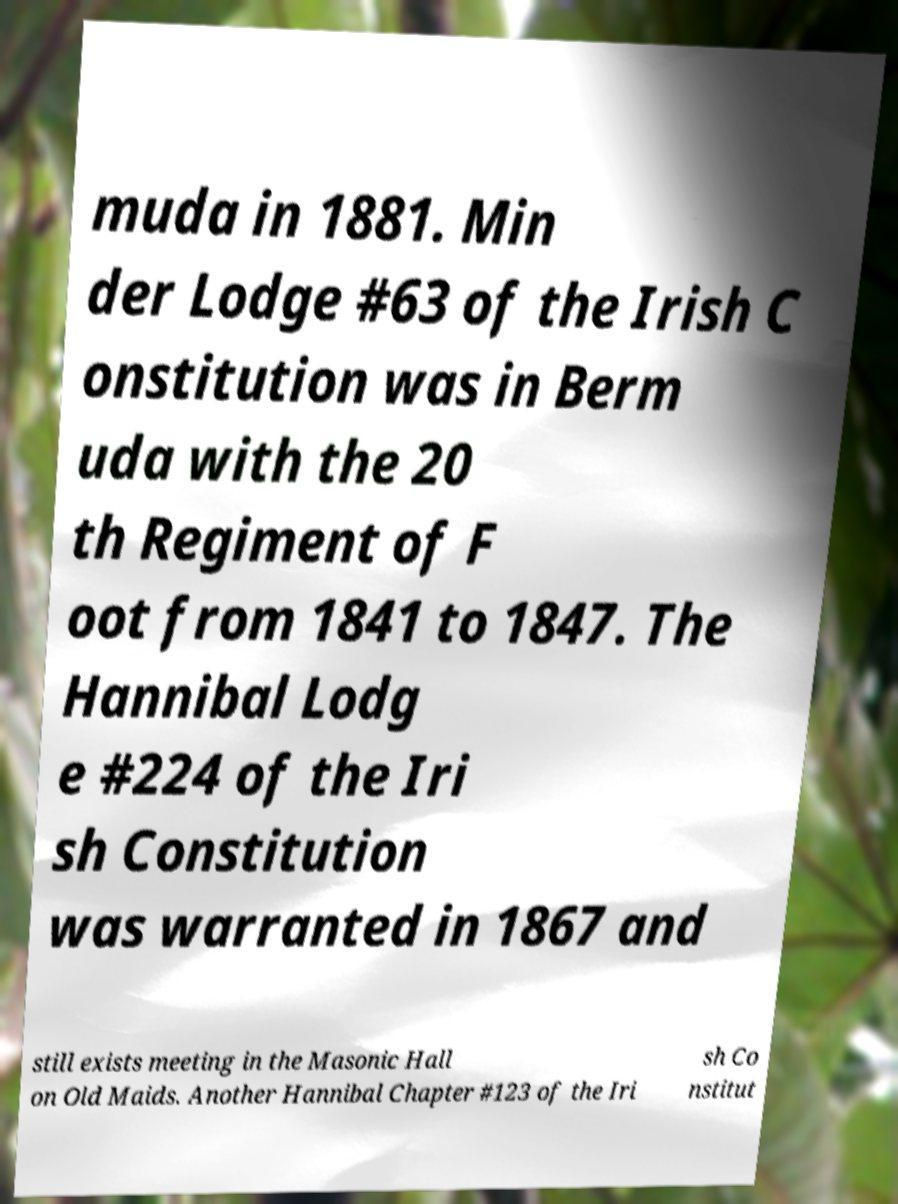For documentation purposes, I need the text within this image transcribed. Could you provide that? muda in 1881. Min der Lodge #63 of the Irish C onstitution was in Berm uda with the 20 th Regiment of F oot from 1841 to 1847. The Hannibal Lodg e #224 of the Iri sh Constitution was warranted in 1867 and still exists meeting in the Masonic Hall on Old Maids. Another Hannibal Chapter #123 of the Iri sh Co nstitut 